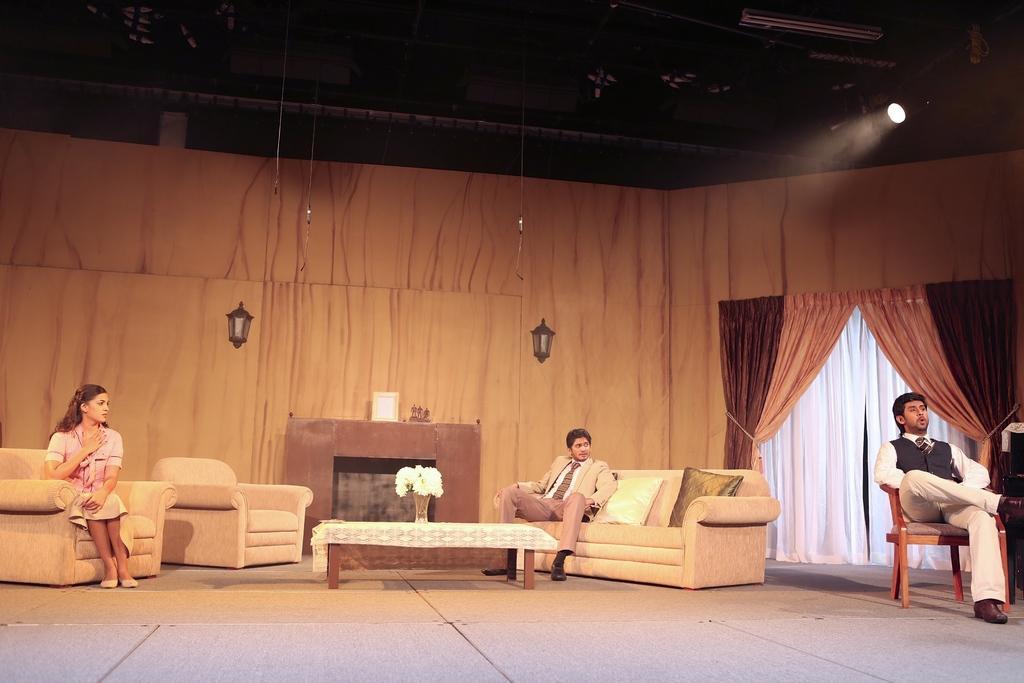Could you give a brief overview of what you see in this image? There are three people in this image, at the right end we can see a guy sitting on a chair and in the center the guy sitting on a couch and in the left side we can see a woman sitting on a chair and in the center there is a table with flower was on it, this looks like they are acting in a play 